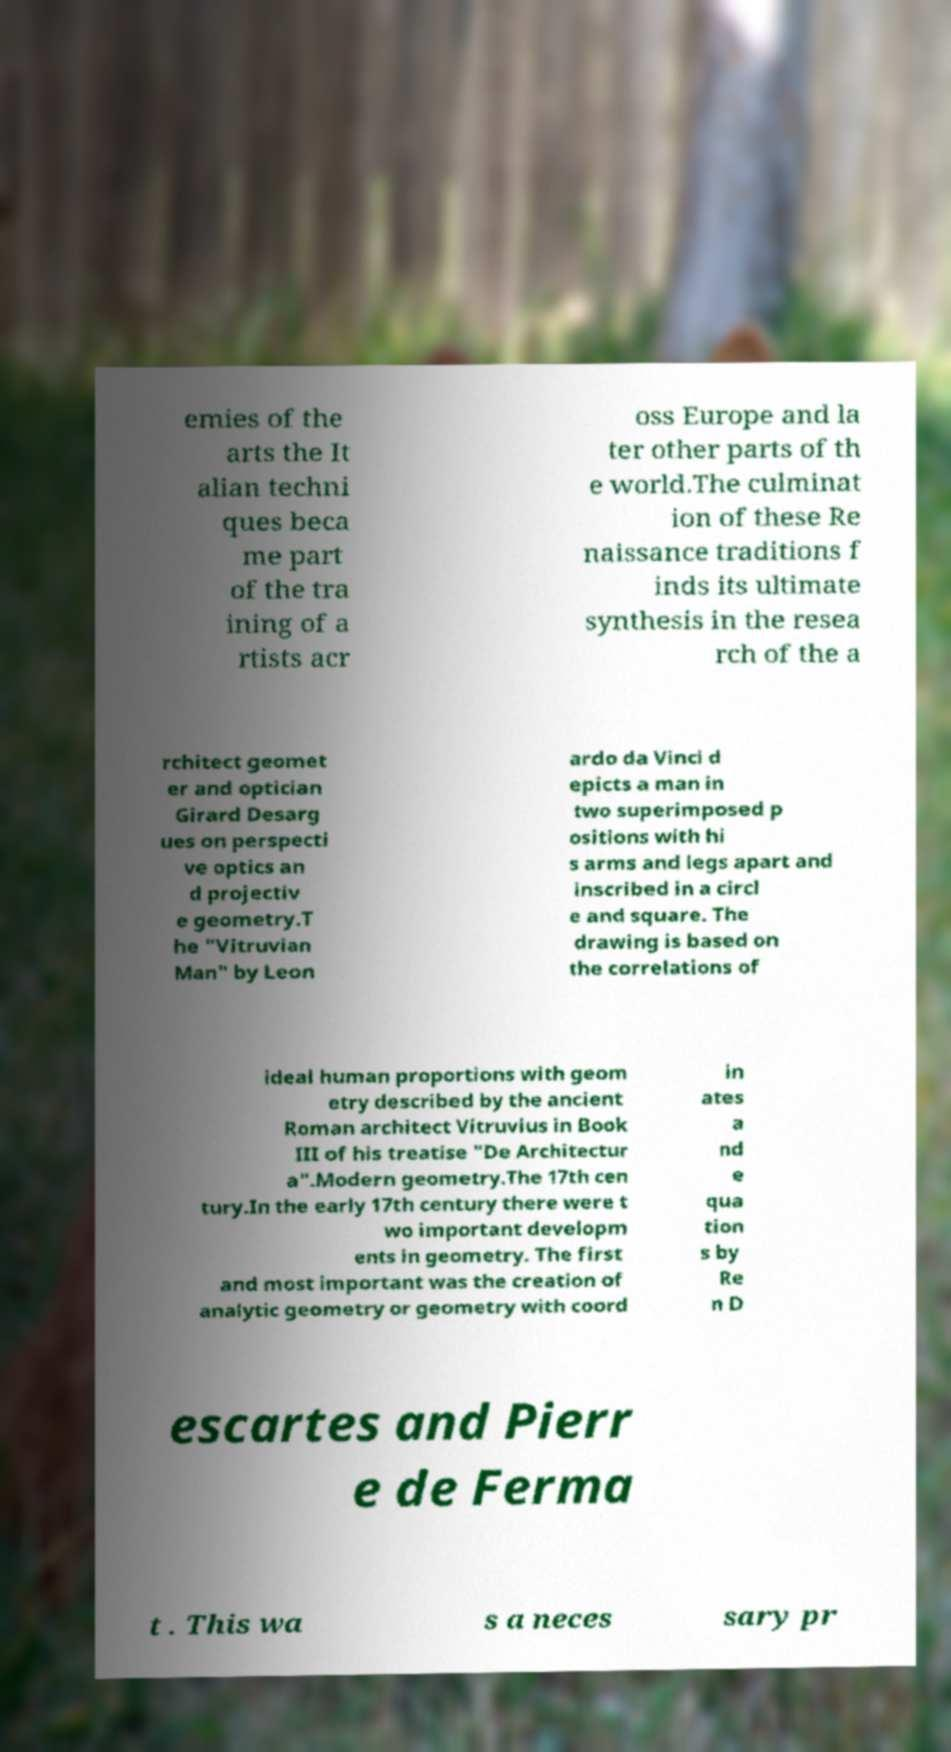I need the written content from this picture converted into text. Can you do that? emies of the arts the It alian techni ques beca me part of the tra ining of a rtists acr oss Europe and la ter other parts of th e world.The culminat ion of these Re naissance traditions f inds its ultimate synthesis in the resea rch of the a rchitect geomet er and optician Girard Desarg ues on perspecti ve optics an d projectiv e geometry.T he "Vitruvian Man" by Leon ardo da Vinci d epicts a man in two superimposed p ositions with hi s arms and legs apart and inscribed in a circl e and square. The drawing is based on the correlations of ideal human proportions with geom etry described by the ancient Roman architect Vitruvius in Book III of his treatise "De Architectur a".Modern geometry.The 17th cen tury.In the early 17th century there were t wo important developm ents in geometry. The first and most important was the creation of analytic geometry or geometry with coord in ates a nd e qua tion s by Re n D escartes and Pierr e de Ferma t . This wa s a neces sary pr 